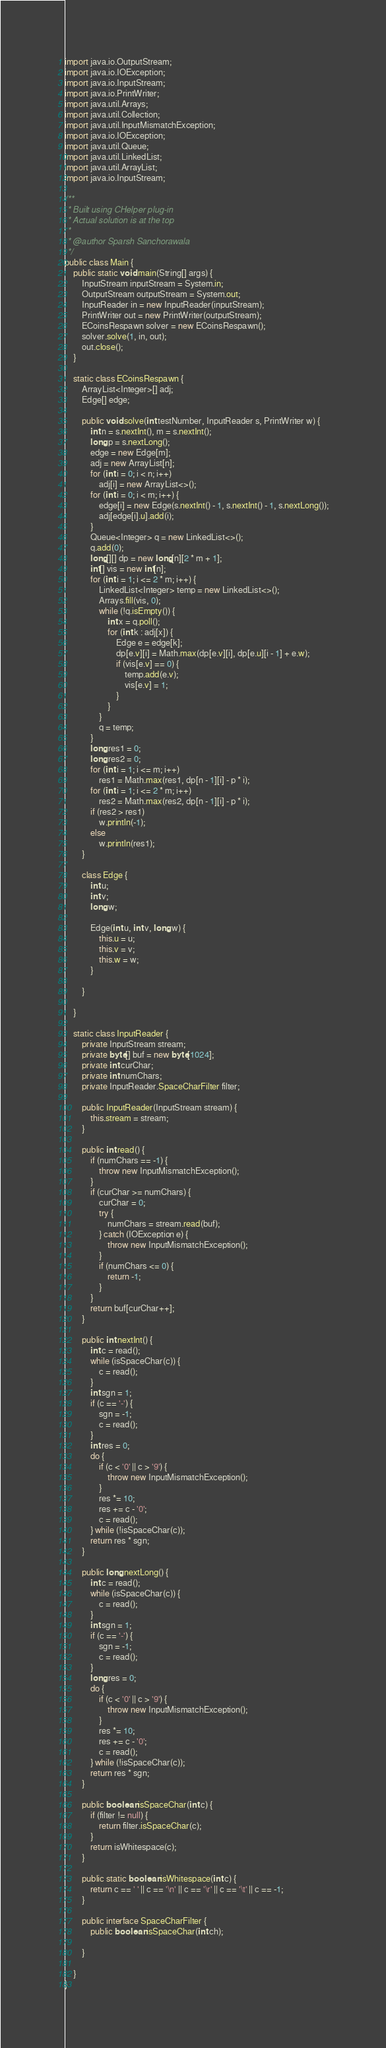<code> <loc_0><loc_0><loc_500><loc_500><_Java_>import java.io.OutputStream;
import java.io.IOException;
import java.io.InputStream;
import java.io.PrintWriter;
import java.util.Arrays;
import java.util.Collection;
import java.util.InputMismatchException;
import java.io.IOException;
import java.util.Queue;
import java.util.LinkedList;
import java.util.ArrayList;
import java.io.InputStream;

/**
 * Built using CHelper plug-in
 * Actual solution is at the top
 *
 * @author Sparsh Sanchorawala
 */
public class Main {
    public static void main(String[] args) {
        InputStream inputStream = System.in;
        OutputStream outputStream = System.out;
        InputReader in = new InputReader(inputStream);
        PrintWriter out = new PrintWriter(outputStream);
        ECoinsRespawn solver = new ECoinsRespawn();
        solver.solve(1, in, out);
        out.close();
    }

    static class ECoinsRespawn {
        ArrayList<Integer>[] adj;
        Edge[] edge;

        public void solve(int testNumber, InputReader s, PrintWriter w) {
            int n = s.nextInt(), m = s.nextInt();
            long p = s.nextLong();
            edge = new Edge[m];
            adj = new ArrayList[n];
            for (int i = 0; i < n; i++)
                adj[i] = new ArrayList<>();
            for (int i = 0; i < m; i++) {
                edge[i] = new Edge(s.nextInt() - 1, s.nextInt() - 1, s.nextLong());
                adj[edge[i].u].add(i);
            }
            Queue<Integer> q = new LinkedList<>();
            q.add(0);
            long[][] dp = new long[n][2 * m + 1];
            int[] vis = new int[n];
            for (int i = 1; i <= 2 * m; i++) {
                LinkedList<Integer> temp = new LinkedList<>();
                Arrays.fill(vis, 0);
                while (!q.isEmpty()) {
                    int x = q.poll();
                    for (int k : adj[x]) {
                        Edge e = edge[k];
                        dp[e.v][i] = Math.max(dp[e.v][i], dp[e.u][i - 1] + e.w);
                        if (vis[e.v] == 0) {
                            temp.add(e.v);
                            vis[e.v] = 1;
                        }
                    }
                }
                q = temp;
            }
            long res1 = 0;
            long res2 = 0;
            for (int i = 1; i <= m; i++)
                res1 = Math.max(res1, dp[n - 1][i] - p * i);
            for (int i = 1; i <= 2 * m; i++)
                res2 = Math.max(res2, dp[n - 1][i] - p * i);
            if (res2 > res1)
                w.println(-1);
            else
                w.println(res1);
        }

        class Edge {
            int u;
            int v;
            long w;

            Edge(int u, int v, long w) {
                this.u = u;
                this.v = v;
                this.w = w;
            }

        }

    }

    static class InputReader {
        private InputStream stream;
        private byte[] buf = new byte[1024];
        private int curChar;
        private int numChars;
        private InputReader.SpaceCharFilter filter;

        public InputReader(InputStream stream) {
            this.stream = stream;
        }

        public int read() {
            if (numChars == -1) {
                throw new InputMismatchException();
            }
            if (curChar >= numChars) {
                curChar = 0;
                try {
                    numChars = stream.read(buf);
                } catch (IOException e) {
                    throw new InputMismatchException();
                }
                if (numChars <= 0) {
                    return -1;
                }
            }
            return buf[curChar++];
        }

        public int nextInt() {
            int c = read();
            while (isSpaceChar(c)) {
                c = read();
            }
            int sgn = 1;
            if (c == '-') {
                sgn = -1;
                c = read();
            }
            int res = 0;
            do {
                if (c < '0' || c > '9') {
                    throw new InputMismatchException();
                }
                res *= 10;
                res += c - '0';
                c = read();
            } while (!isSpaceChar(c));
            return res * sgn;
        }

        public long nextLong() {
            int c = read();
            while (isSpaceChar(c)) {
                c = read();
            }
            int sgn = 1;
            if (c == '-') {
                sgn = -1;
                c = read();
            }
            long res = 0;
            do {
                if (c < '0' || c > '9') {
                    throw new InputMismatchException();
                }
                res *= 10;
                res += c - '0';
                c = read();
            } while (!isSpaceChar(c));
            return res * sgn;
        }

        public boolean isSpaceChar(int c) {
            if (filter != null) {
                return filter.isSpaceChar(c);
            }
            return isWhitespace(c);
        }

        public static boolean isWhitespace(int c) {
            return c == ' ' || c == '\n' || c == '\r' || c == '\t' || c == -1;
        }

        public interface SpaceCharFilter {
            public boolean isSpaceChar(int ch);

        }

    }
}

</code> 